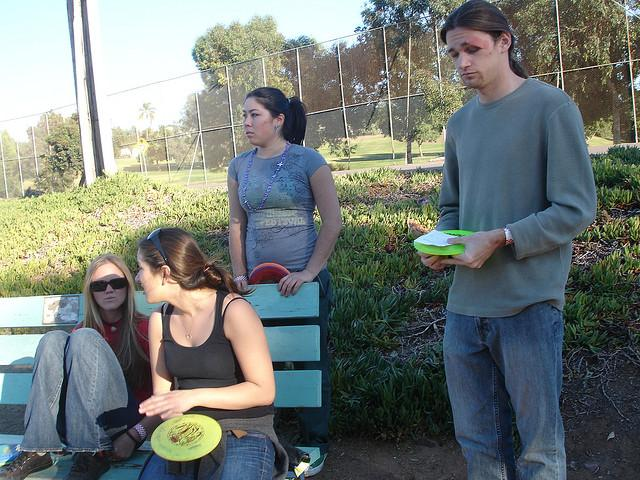What are they doing? eating 